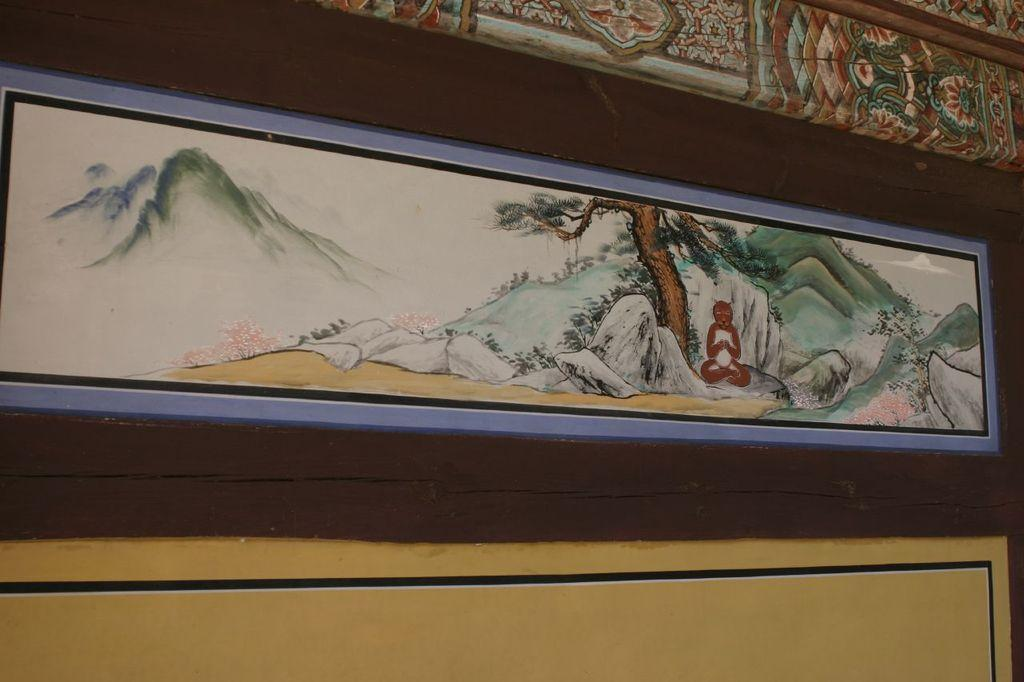What is hanging on the wall in the image? There is a frame on the wall in the image. Where is the frame located in relation to the image? The frame is in the center of the image. What type of stick is depicted in the frame in the image? There is no stick depicted in the frame in the image; the frame contains an unspecified image or artwork. 